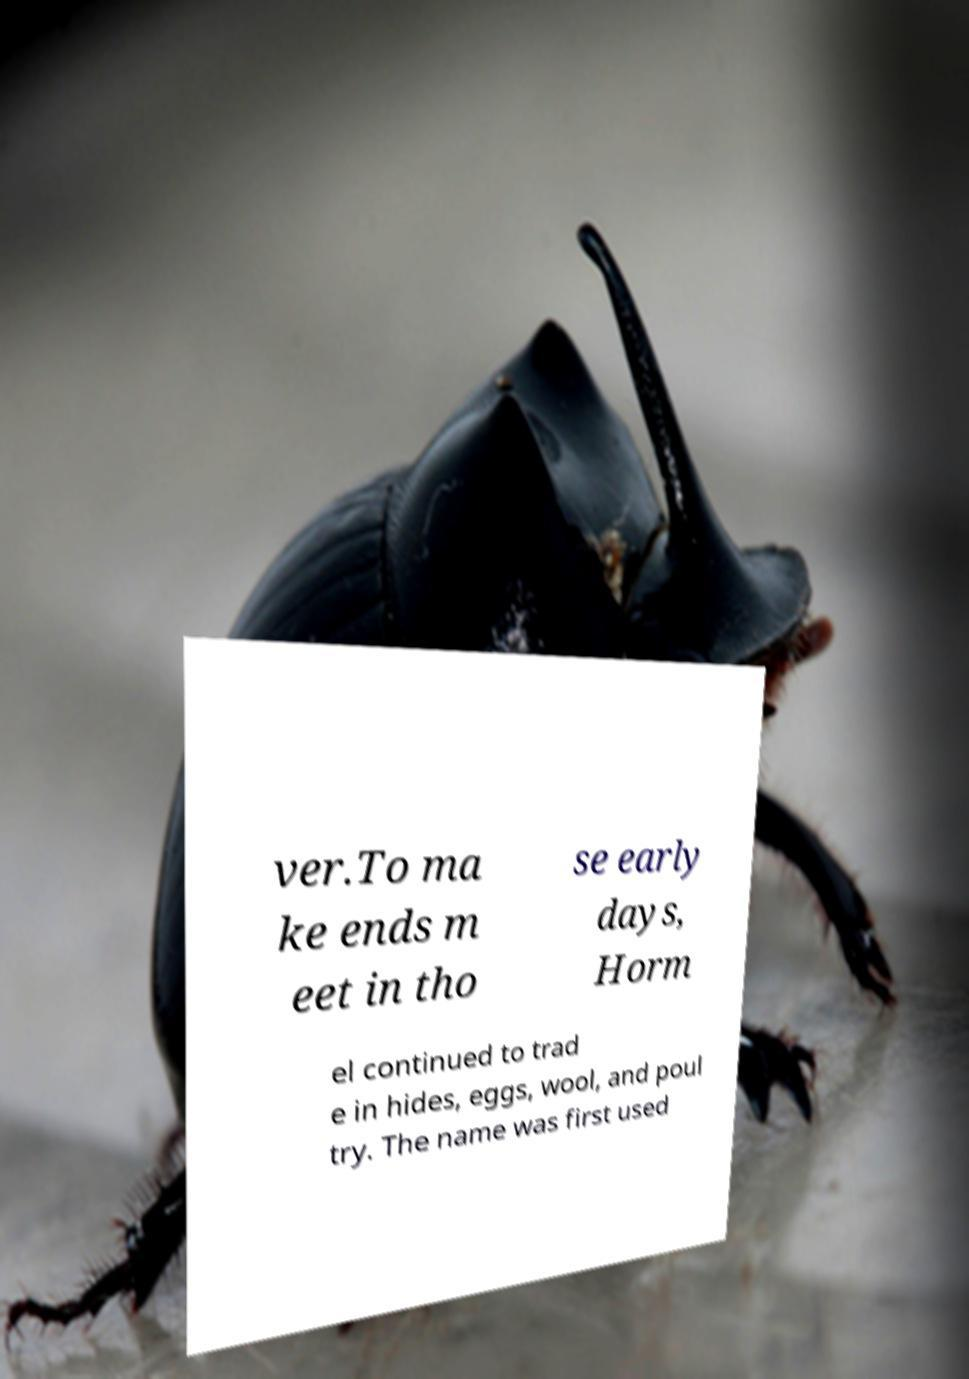What messages or text are displayed in this image? I need them in a readable, typed format. ver.To ma ke ends m eet in tho se early days, Horm el continued to trad e in hides, eggs, wool, and poul try. The name was first used 